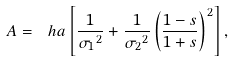<formula> <loc_0><loc_0><loc_500><loc_500>A = \ h a \left [ \frac { 1 } { { \sigma _ { 1 } } ^ { 2 } } + \frac { 1 } { { \sigma _ { 2 } } ^ { 2 } } \left ( \frac { 1 - s } { 1 + s } \right ) ^ { 2 } \right ] ,</formula> 